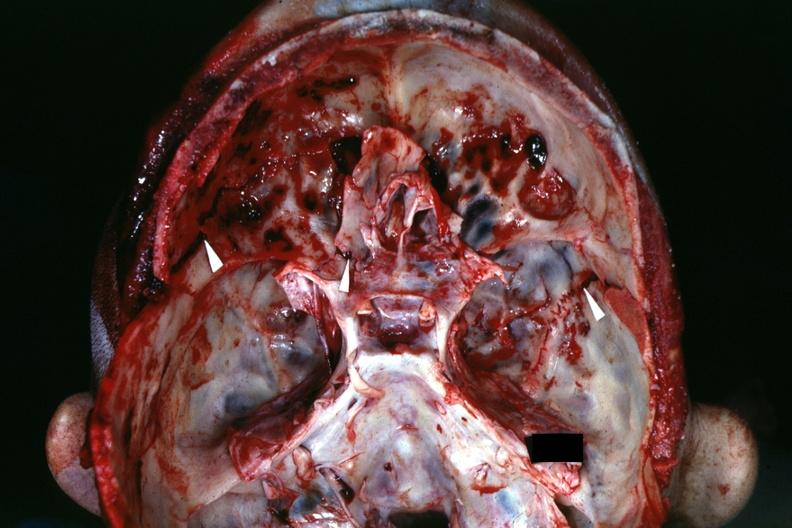s bone, calvarium present?
Answer the question using a single word or phrase. Yes 